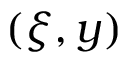Convert formula to latex. <formula><loc_0><loc_0><loc_500><loc_500>( \xi , y )</formula> 